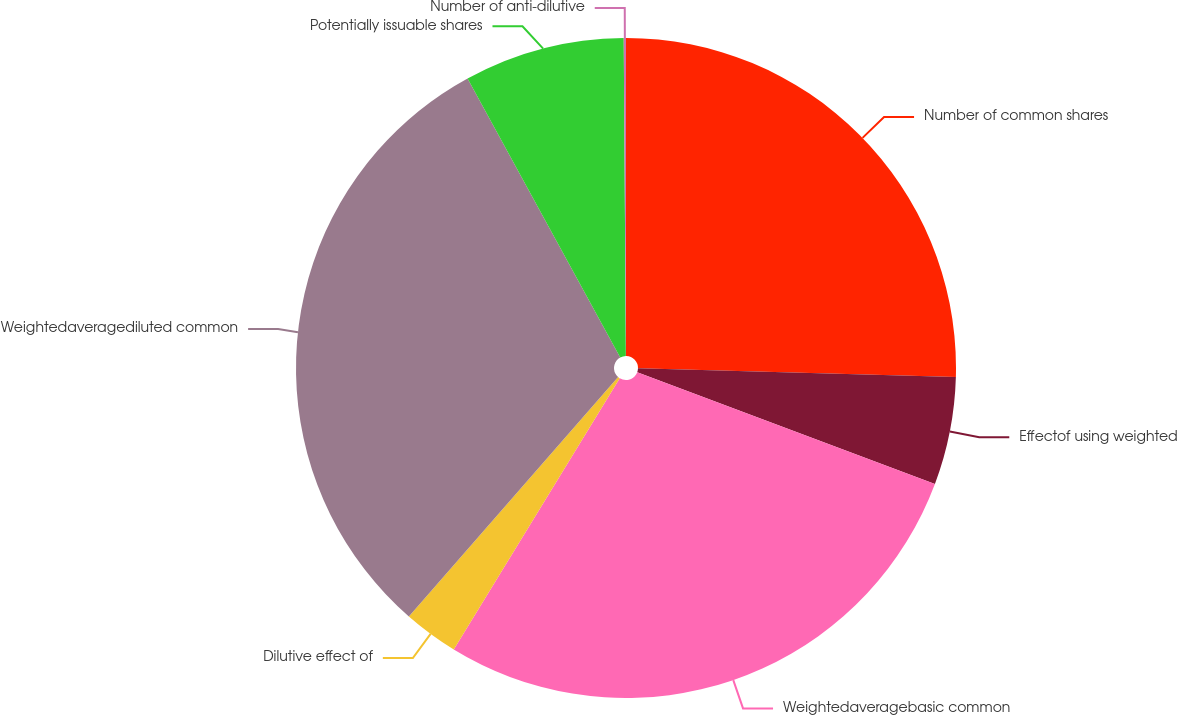Convert chart to OTSL. <chart><loc_0><loc_0><loc_500><loc_500><pie_chart><fcel>Number of common shares<fcel>Effectof using weighted<fcel>Weightedaveragebasic common<fcel>Dilutive effect of<fcel>Weightedaveragediluted common<fcel>Potentially issuable shares<fcel>Number of anti-dilutive<nl><fcel>25.44%<fcel>5.28%<fcel>28.02%<fcel>2.69%<fcel>30.6%<fcel>7.86%<fcel>0.11%<nl></chart> 